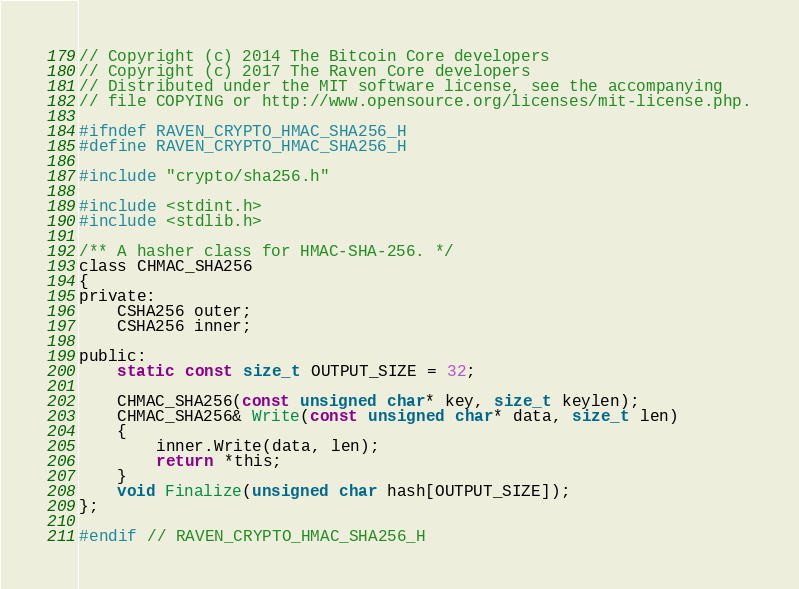<code> <loc_0><loc_0><loc_500><loc_500><_C_>// Copyright (c) 2014 The Bitcoin Core developers
// Copyright (c) 2017 The Raven Core developers
// Distributed under the MIT software license, see the accompanying
// file COPYING or http://www.opensource.org/licenses/mit-license.php.

#ifndef RAVEN_CRYPTO_HMAC_SHA256_H
#define RAVEN_CRYPTO_HMAC_SHA256_H

#include "crypto/sha256.h"

#include <stdint.h>
#include <stdlib.h>

/** A hasher class for HMAC-SHA-256. */
class CHMAC_SHA256
{
private:
    CSHA256 outer;
    CSHA256 inner;

public:
    static const size_t OUTPUT_SIZE = 32;

    CHMAC_SHA256(const unsigned char* key, size_t keylen);
    CHMAC_SHA256& Write(const unsigned char* data, size_t len)
    {
        inner.Write(data, len);
        return *this;
    }
    void Finalize(unsigned char hash[OUTPUT_SIZE]);
};

#endif // RAVEN_CRYPTO_HMAC_SHA256_H
</code> 